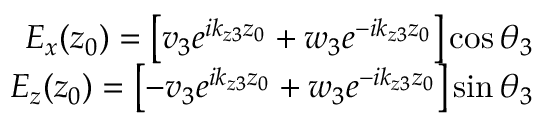<formula> <loc_0><loc_0><loc_500><loc_500>\begin{array} { r } { E _ { x } ( z _ { 0 } ) = \left [ v _ { 3 } e ^ { i k _ { z 3 } z _ { 0 } } + w _ { 3 } e ^ { - i k _ { z 3 } z _ { 0 } } \right ] \cos \, \theta _ { 3 } } \\ { E _ { z } ( z _ { 0 } ) = \left [ - v _ { 3 } e ^ { i k _ { z 3 } z _ { 0 } } + w _ { 3 } e ^ { - i k _ { z 3 } z _ { 0 } } \right ] \sin \, \theta _ { 3 } } \end{array}</formula> 